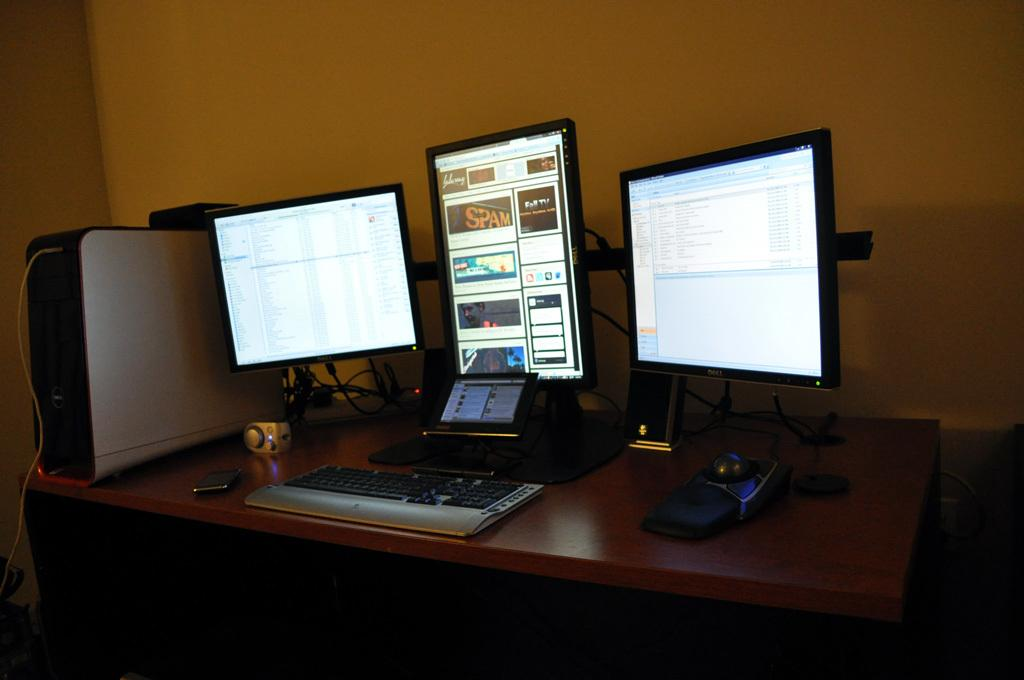What is the main piece of furniture in the image? There is a table in the image. What electronic device is on the table? There is a computer system on the table. What is the central component of the computer system? The computer system includes a CPU. What other device is on the table? There is a mobile phone on the table. What else can be seen on the table? There are wires and a keyboard visible on the table. What can be seen in the background of the image? There is a wall visible in the background of the image. What type of plantation is visible in the image? There is no plantation present in the image; it features a table with electronic devices and other items. What is the weight of the CPU in the image? The weight of the CPU cannot be determined from the image alone, as it requires additional information about the specific model and its components. 